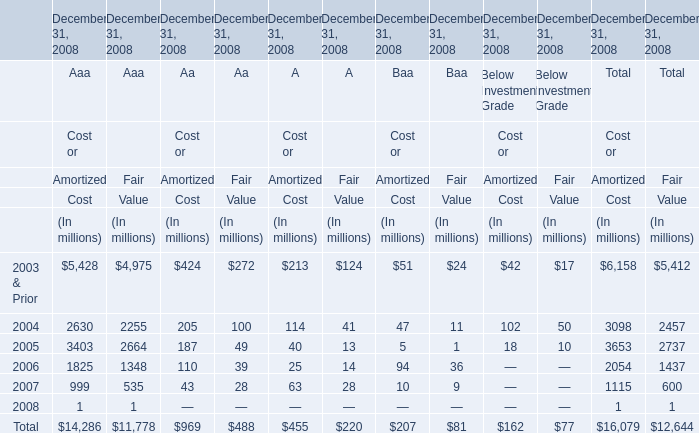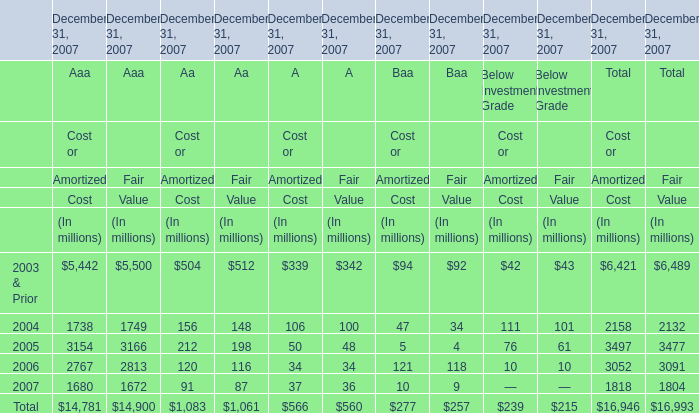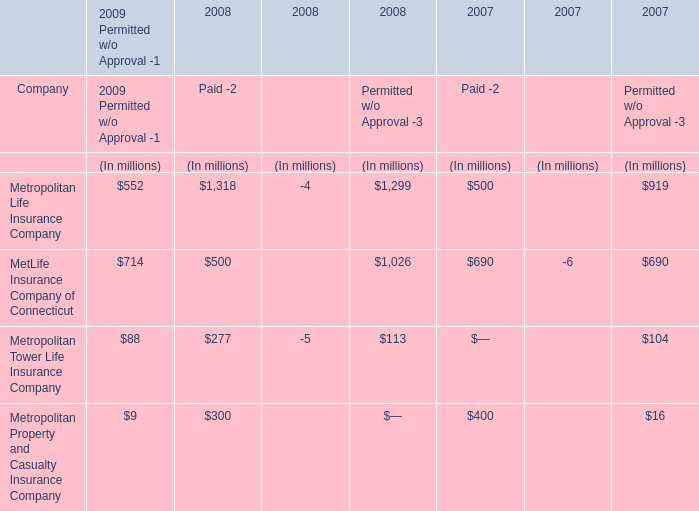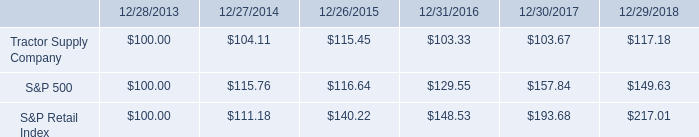What's the greatest value of Aaa in 2003 for Cost? 
Answer: 5428. 